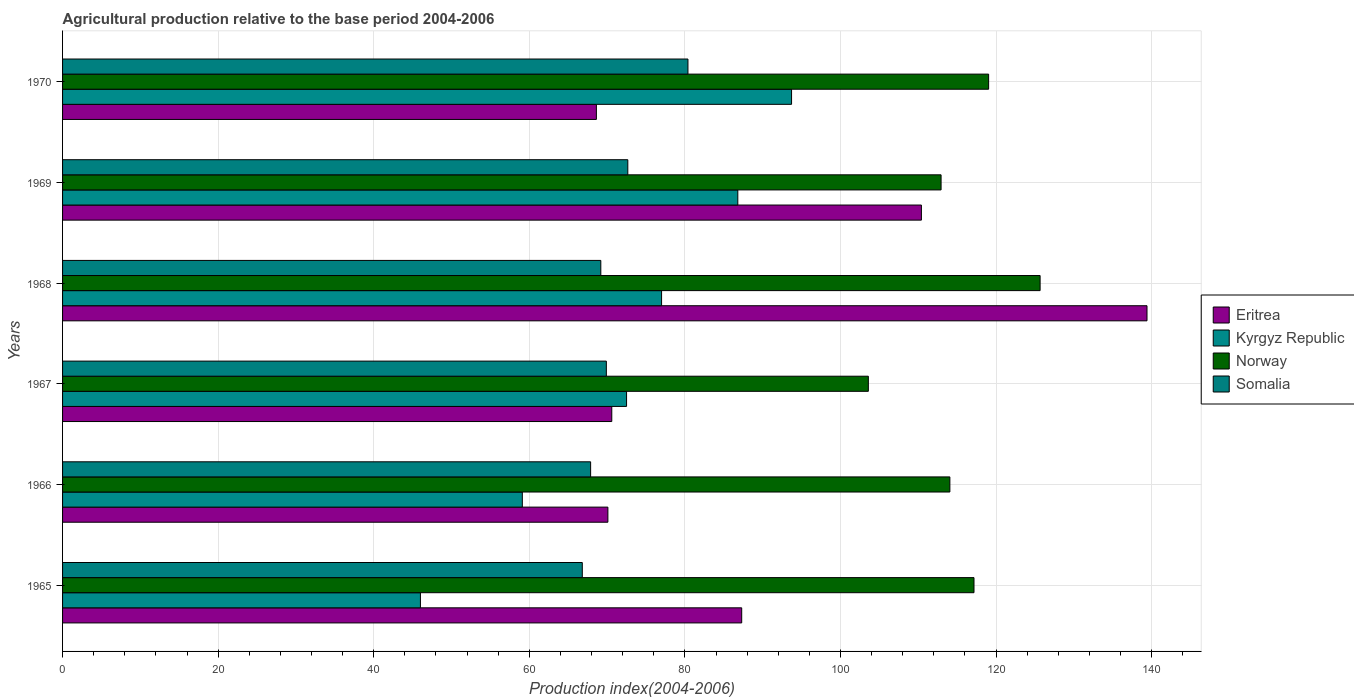How many different coloured bars are there?
Your response must be concise. 4. How many bars are there on the 6th tick from the bottom?
Give a very brief answer. 4. What is the label of the 4th group of bars from the top?
Keep it short and to the point. 1967. In how many cases, is the number of bars for a given year not equal to the number of legend labels?
Keep it short and to the point. 0. What is the agricultural production index in Eritrea in 1965?
Keep it short and to the point. 87.3. Across all years, what is the maximum agricultural production index in Somalia?
Your answer should be compact. 80.39. In which year was the agricultural production index in Somalia maximum?
Offer a very short reply. 1970. What is the total agricultural production index in Somalia in the graph?
Provide a short and direct response. 426.83. What is the difference between the agricultural production index in Eritrea in 1967 and that in 1969?
Offer a very short reply. -39.8. What is the difference between the agricultural production index in Somalia in 1970 and the agricultural production index in Norway in 1965?
Your response must be concise. -36.77. What is the average agricultural production index in Eritrea per year?
Offer a terse response. 91.07. In the year 1966, what is the difference between the agricultural production index in Eritrea and agricultural production index in Norway?
Ensure brevity in your answer.  -43.96. In how many years, is the agricultural production index in Kyrgyz Republic greater than 12 ?
Provide a succinct answer. 6. What is the ratio of the agricultural production index in Kyrgyz Republic in 1967 to that in 1970?
Your answer should be very brief. 0.77. Is the agricultural production index in Eritrea in 1965 less than that in 1969?
Make the answer very short. Yes. What is the difference between the highest and the second highest agricultural production index in Kyrgyz Republic?
Your answer should be very brief. 6.91. What is the difference between the highest and the lowest agricultural production index in Kyrgyz Republic?
Give a very brief answer. 47.71. In how many years, is the agricultural production index in Eritrea greater than the average agricultural production index in Eritrea taken over all years?
Offer a terse response. 2. What does the 1st bar from the top in 1969 represents?
Offer a terse response. Somalia. Is it the case that in every year, the sum of the agricultural production index in Norway and agricultural production index in Kyrgyz Republic is greater than the agricultural production index in Eritrea?
Ensure brevity in your answer.  Yes. How many years are there in the graph?
Ensure brevity in your answer.  6. Does the graph contain grids?
Give a very brief answer. Yes. Where does the legend appear in the graph?
Give a very brief answer. Center right. How many legend labels are there?
Give a very brief answer. 4. What is the title of the graph?
Provide a short and direct response. Agricultural production relative to the base period 2004-2006. Does "New Caledonia" appear as one of the legend labels in the graph?
Give a very brief answer. No. What is the label or title of the X-axis?
Provide a short and direct response. Production index(2004-2006). What is the label or title of the Y-axis?
Provide a short and direct response. Years. What is the Production index(2004-2006) of Eritrea in 1965?
Keep it short and to the point. 87.3. What is the Production index(2004-2006) in Norway in 1965?
Give a very brief answer. 117.16. What is the Production index(2004-2006) of Somalia in 1965?
Keep it short and to the point. 66.81. What is the Production index(2004-2006) of Eritrea in 1966?
Your answer should be very brief. 70.1. What is the Production index(2004-2006) in Kyrgyz Republic in 1966?
Keep it short and to the point. 59.1. What is the Production index(2004-2006) in Norway in 1966?
Keep it short and to the point. 114.06. What is the Production index(2004-2006) of Somalia in 1966?
Keep it short and to the point. 67.88. What is the Production index(2004-2006) in Eritrea in 1967?
Offer a very short reply. 70.6. What is the Production index(2004-2006) in Kyrgyz Republic in 1967?
Provide a succinct answer. 72.5. What is the Production index(2004-2006) of Norway in 1967?
Provide a short and direct response. 103.58. What is the Production index(2004-2006) of Somalia in 1967?
Provide a short and direct response. 69.9. What is the Production index(2004-2006) of Eritrea in 1968?
Offer a terse response. 139.4. What is the Production index(2004-2006) of Norway in 1968?
Give a very brief answer. 125.66. What is the Production index(2004-2006) of Somalia in 1968?
Keep it short and to the point. 69.19. What is the Production index(2004-2006) in Eritrea in 1969?
Offer a very short reply. 110.4. What is the Production index(2004-2006) of Kyrgyz Republic in 1969?
Offer a very short reply. 86.8. What is the Production index(2004-2006) in Norway in 1969?
Your response must be concise. 112.93. What is the Production index(2004-2006) in Somalia in 1969?
Your answer should be very brief. 72.66. What is the Production index(2004-2006) of Eritrea in 1970?
Offer a terse response. 68.62. What is the Production index(2004-2006) in Kyrgyz Republic in 1970?
Provide a succinct answer. 93.71. What is the Production index(2004-2006) of Norway in 1970?
Your response must be concise. 119.04. What is the Production index(2004-2006) of Somalia in 1970?
Offer a very short reply. 80.39. Across all years, what is the maximum Production index(2004-2006) in Eritrea?
Offer a terse response. 139.4. Across all years, what is the maximum Production index(2004-2006) of Kyrgyz Republic?
Your answer should be compact. 93.71. Across all years, what is the maximum Production index(2004-2006) in Norway?
Provide a succinct answer. 125.66. Across all years, what is the maximum Production index(2004-2006) of Somalia?
Offer a terse response. 80.39. Across all years, what is the minimum Production index(2004-2006) of Eritrea?
Your answer should be compact. 68.62. Across all years, what is the minimum Production index(2004-2006) in Kyrgyz Republic?
Offer a terse response. 46. Across all years, what is the minimum Production index(2004-2006) of Norway?
Your response must be concise. 103.58. Across all years, what is the minimum Production index(2004-2006) of Somalia?
Offer a very short reply. 66.81. What is the total Production index(2004-2006) in Eritrea in the graph?
Give a very brief answer. 546.42. What is the total Production index(2004-2006) in Kyrgyz Republic in the graph?
Your answer should be very brief. 435.11. What is the total Production index(2004-2006) in Norway in the graph?
Provide a short and direct response. 692.43. What is the total Production index(2004-2006) of Somalia in the graph?
Give a very brief answer. 426.83. What is the difference between the Production index(2004-2006) in Kyrgyz Republic in 1965 and that in 1966?
Keep it short and to the point. -13.1. What is the difference between the Production index(2004-2006) in Norway in 1965 and that in 1966?
Ensure brevity in your answer.  3.1. What is the difference between the Production index(2004-2006) of Somalia in 1965 and that in 1966?
Offer a very short reply. -1.07. What is the difference between the Production index(2004-2006) in Eritrea in 1965 and that in 1967?
Your answer should be compact. 16.7. What is the difference between the Production index(2004-2006) in Kyrgyz Republic in 1965 and that in 1967?
Make the answer very short. -26.5. What is the difference between the Production index(2004-2006) in Norway in 1965 and that in 1967?
Ensure brevity in your answer.  13.58. What is the difference between the Production index(2004-2006) of Somalia in 1965 and that in 1967?
Your response must be concise. -3.09. What is the difference between the Production index(2004-2006) of Eritrea in 1965 and that in 1968?
Your response must be concise. -52.1. What is the difference between the Production index(2004-2006) of Kyrgyz Republic in 1965 and that in 1968?
Your answer should be compact. -31. What is the difference between the Production index(2004-2006) in Somalia in 1965 and that in 1968?
Provide a short and direct response. -2.38. What is the difference between the Production index(2004-2006) of Eritrea in 1965 and that in 1969?
Give a very brief answer. -23.1. What is the difference between the Production index(2004-2006) in Kyrgyz Republic in 1965 and that in 1969?
Make the answer very short. -40.8. What is the difference between the Production index(2004-2006) of Norway in 1965 and that in 1969?
Offer a terse response. 4.23. What is the difference between the Production index(2004-2006) in Somalia in 1965 and that in 1969?
Offer a terse response. -5.85. What is the difference between the Production index(2004-2006) of Eritrea in 1965 and that in 1970?
Your answer should be very brief. 18.68. What is the difference between the Production index(2004-2006) of Kyrgyz Republic in 1965 and that in 1970?
Offer a very short reply. -47.71. What is the difference between the Production index(2004-2006) in Norway in 1965 and that in 1970?
Your answer should be very brief. -1.88. What is the difference between the Production index(2004-2006) of Somalia in 1965 and that in 1970?
Offer a terse response. -13.58. What is the difference between the Production index(2004-2006) of Norway in 1966 and that in 1967?
Your answer should be very brief. 10.48. What is the difference between the Production index(2004-2006) of Somalia in 1966 and that in 1967?
Provide a succinct answer. -2.02. What is the difference between the Production index(2004-2006) of Eritrea in 1966 and that in 1968?
Your answer should be very brief. -69.3. What is the difference between the Production index(2004-2006) of Kyrgyz Republic in 1966 and that in 1968?
Give a very brief answer. -17.9. What is the difference between the Production index(2004-2006) of Somalia in 1966 and that in 1968?
Your answer should be very brief. -1.31. What is the difference between the Production index(2004-2006) of Eritrea in 1966 and that in 1969?
Offer a terse response. -40.3. What is the difference between the Production index(2004-2006) in Kyrgyz Republic in 1966 and that in 1969?
Your answer should be compact. -27.7. What is the difference between the Production index(2004-2006) of Norway in 1966 and that in 1969?
Offer a terse response. 1.13. What is the difference between the Production index(2004-2006) in Somalia in 1966 and that in 1969?
Your response must be concise. -4.78. What is the difference between the Production index(2004-2006) in Eritrea in 1966 and that in 1970?
Your answer should be very brief. 1.48. What is the difference between the Production index(2004-2006) in Kyrgyz Republic in 1966 and that in 1970?
Offer a terse response. -34.61. What is the difference between the Production index(2004-2006) in Norway in 1966 and that in 1970?
Provide a succinct answer. -4.98. What is the difference between the Production index(2004-2006) in Somalia in 1966 and that in 1970?
Your answer should be very brief. -12.51. What is the difference between the Production index(2004-2006) of Eritrea in 1967 and that in 1968?
Provide a short and direct response. -68.8. What is the difference between the Production index(2004-2006) of Norway in 1967 and that in 1968?
Your answer should be very brief. -22.08. What is the difference between the Production index(2004-2006) of Somalia in 1967 and that in 1968?
Your answer should be compact. 0.71. What is the difference between the Production index(2004-2006) in Eritrea in 1967 and that in 1969?
Provide a succinct answer. -39.8. What is the difference between the Production index(2004-2006) of Kyrgyz Republic in 1967 and that in 1969?
Your answer should be compact. -14.3. What is the difference between the Production index(2004-2006) in Norway in 1967 and that in 1969?
Keep it short and to the point. -9.35. What is the difference between the Production index(2004-2006) in Somalia in 1967 and that in 1969?
Keep it short and to the point. -2.76. What is the difference between the Production index(2004-2006) in Eritrea in 1967 and that in 1970?
Your answer should be compact. 1.98. What is the difference between the Production index(2004-2006) in Kyrgyz Republic in 1967 and that in 1970?
Ensure brevity in your answer.  -21.21. What is the difference between the Production index(2004-2006) of Norway in 1967 and that in 1970?
Provide a short and direct response. -15.46. What is the difference between the Production index(2004-2006) of Somalia in 1967 and that in 1970?
Keep it short and to the point. -10.49. What is the difference between the Production index(2004-2006) of Kyrgyz Republic in 1968 and that in 1969?
Your answer should be very brief. -9.8. What is the difference between the Production index(2004-2006) of Norway in 1968 and that in 1969?
Give a very brief answer. 12.73. What is the difference between the Production index(2004-2006) of Somalia in 1968 and that in 1969?
Offer a very short reply. -3.47. What is the difference between the Production index(2004-2006) in Eritrea in 1968 and that in 1970?
Keep it short and to the point. 70.78. What is the difference between the Production index(2004-2006) of Kyrgyz Republic in 1968 and that in 1970?
Your response must be concise. -16.71. What is the difference between the Production index(2004-2006) in Norway in 1968 and that in 1970?
Provide a short and direct response. 6.62. What is the difference between the Production index(2004-2006) in Somalia in 1968 and that in 1970?
Your answer should be compact. -11.2. What is the difference between the Production index(2004-2006) of Eritrea in 1969 and that in 1970?
Your response must be concise. 41.78. What is the difference between the Production index(2004-2006) in Kyrgyz Republic in 1969 and that in 1970?
Offer a very short reply. -6.91. What is the difference between the Production index(2004-2006) in Norway in 1969 and that in 1970?
Provide a succinct answer. -6.11. What is the difference between the Production index(2004-2006) in Somalia in 1969 and that in 1970?
Your response must be concise. -7.73. What is the difference between the Production index(2004-2006) of Eritrea in 1965 and the Production index(2004-2006) of Kyrgyz Republic in 1966?
Provide a short and direct response. 28.2. What is the difference between the Production index(2004-2006) of Eritrea in 1965 and the Production index(2004-2006) of Norway in 1966?
Keep it short and to the point. -26.76. What is the difference between the Production index(2004-2006) in Eritrea in 1965 and the Production index(2004-2006) in Somalia in 1966?
Provide a succinct answer. 19.42. What is the difference between the Production index(2004-2006) in Kyrgyz Republic in 1965 and the Production index(2004-2006) in Norway in 1966?
Your response must be concise. -68.06. What is the difference between the Production index(2004-2006) in Kyrgyz Republic in 1965 and the Production index(2004-2006) in Somalia in 1966?
Make the answer very short. -21.88. What is the difference between the Production index(2004-2006) of Norway in 1965 and the Production index(2004-2006) of Somalia in 1966?
Keep it short and to the point. 49.28. What is the difference between the Production index(2004-2006) of Eritrea in 1965 and the Production index(2004-2006) of Norway in 1967?
Make the answer very short. -16.28. What is the difference between the Production index(2004-2006) in Kyrgyz Republic in 1965 and the Production index(2004-2006) in Norway in 1967?
Make the answer very short. -57.58. What is the difference between the Production index(2004-2006) in Kyrgyz Republic in 1965 and the Production index(2004-2006) in Somalia in 1967?
Your response must be concise. -23.9. What is the difference between the Production index(2004-2006) in Norway in 1965 and the Production index(2004-2006) in Somalia in 1967?
Your response must be concise. 47.26. What is the difference between the Production index(2004-2006) of Eritrea in 1965 and the Production index(2004-2006) of Kyrgyz Republic in 1968?
Your response must be concise. 10.3. What is the difference between the Production index(2004-2006) of Eritrea in 1965 and the Production index(2004-2006) of Norway in 1968?
Give a very brief answer. -38.36. What is the difference between the Production index(2004-2006) in Eritrea in 1965 and the Production index(2004-2006) in Somalia in 1968?
Offer a very short reply. 18.11. What is the difference between the Production index(2004-2006) of Kyrgyz Republic in 1965 and the Production index(2004-2006) of Norway in 1968?
Your response must be concise. -79.66. What is the difference between the Production index(2004-2006) of Kyrgyz Republic in 1965 and the Production index(2004-2006) of Somalia in 1968?
Ensure brevity in your answer.  -23.19. What is the difference between the Production index(2004-2006) of Norway in 1965 and the Production index(2004-2006) of Somalia in 1968?
Ensure brevity in your answer.  47.97. What is the difference between the Production index(2004-2006) of Eritrea in 1965 and the Production index(2004-2006) of Norway in 1969?
Make the answer very short. -25.63. What is the difference between the Production index(2004-2006) of Eritrea in 1965 and the Production index(2004-2006) of Somalia in 1969?
Keep it short and to the point. 14.64. What is the difference between the Production index(2004-2006) of Kyrgyz Republic in 1965 and the Production index(2004-2006) of Norway in 1969?
Give a very brief answer. -66.93. What is the difference between the Production index(2004-2006) of Kyrgyz Republic in 1965 and the Production index(2004-2006) of Somalia in 1969?
Offer a terse response. -26.66. What is the difference between the Production index(2004-2006) of Norway in 1965 and the Production index(2004-2006) of Somalia in 1969?
Your response must be concise. 44.5. What is the difference between the Production index(2004-2006) of Eritrea in 1965 and the Production index(2004-2006) of Kyrgyz Republic in 1970?
Keep it short and to the point. -6.41. What is the difference between the Production index(2004-2006) in Eritrea in 1965 and the Production index(2004-2006) in Norway in 1970?
Your response must be concise. -31.74. What is the difference between the Production index(2004-2006) of Eritrea in 1965 and the Production index(2004-2006) of Somalia in 1970?
Keep it short and to the point. 6.91. What is the difference between the Production index(2004-2006) of Kyrgyz Republic in 1965 and the Production index(2004-2006) of Norway in 1970?
Ensure brevity in your answer.  -73.04. What is the difference between the Production index(2004-2006) of Kyrgyz Republic in 1965 and the Production index(2004-2006) of Somalia in 1970?
Provide a short and direct response. -34.39. What is the difference between the Production index(2004-2006) in Norway in 1965 and the Production index(2004-2006) in Somalia in 1970?
Make the answer very short. 36.77. What is the difference between the Production index(2004-2006) in Eritrea in 1966 and the Production index(2004-2006) in Norway in 1967?
Your answer should be compact. -33.48. What is the difference between the Production index(2004-2006) in Eritrea in 1966 and the Production index(2004-2006) in Somalia in 1967?
Offer a terse response. 0.2. What is the difference between the Production index(2004-2006) of Kyrgyz Republic in 1966 and the Production index(2004-2006) of Norway in 1967?
Offer a terse response. -44.48. What is the difference between the Production index(2004-2006) of Kyrgyz Republic in 1966 and the Production index(2004-2006) of Somalia in 1967?
Offer a terse response. -10.8. What is the difference between the Production index(2004-2006) of Norway in 1966 and the Production index(2004-2006) of Somalia in 1967?
Your response must be concise. 44.16. What is the difference between the Production index(2004-2006) of Eritrea in 1966 and the Production index(2004-2006) of Norway in 1968?
Your answer should be very brief. -55.56. What is the difference between the Production index(2004-2006) in Eritrea in 1966 and the Production index(2004-2006) in Somalia in 1968?
Ensure brevity in your answer.  0.91. What is the difference between the Production index(2004-2006) in Kyrgyz Republic in 1966 and the Production index(2004-2006) in Norway in 1968?
Your answer should be very brief. -66.56. What is the difference between the Production index(2004-2006) of Kyrgyz Republic in 1966 and the Production index(2004-2006) of Somalia in 1968?
Offer a terse response. -10.09. What is the difference between the Production index(2004-2006) in Norway in 1966 and the Production index(2004-2006) in Somalia in 1968?
Make the answer very short. 44.87. What is the difference between the Production index(2004-2006) of Eritrea in 1966 and the Production index(2004-2006) of Kyrgyz Republic in 1969?
Offer a terse response. -16.7. What is the difference between the Production index(2004-2006) of Eritrea in 1966 and the Production index(2004-2006) of Norway in 1969?
Make the answer very short. -42.83. What is the difference between the Production index(2004-2006) in Eritrea in 1966 and the Production index(2004-2006) in Somalia in 1969?
Offer a very short reply. -2.56. What is the difference between the Production index(2004-2006) of Kyrgyz Republic in 1966 and the Production index(2004-2006) of Norway in 1969?
Give a very brief answer. -53.83. What is the difference between the Production index(2004-2006) in Kyrgyz Republic in 1966 and the Production index(2004-2006) in Somalia in 1969?
Provide a short and direct response. -13.56. What is the difference between the Production index(2004-2006) in Norway in 1966 and the Production index(2004-2006) in Somalia in 1969?
Offer a very short reply. 41.4. What is the difference between the Production index(2004-2006) in Eritrea in 1966 and the Production index(2004-2006) in Kyrgyz Republic in 1970?
Provide a short and direct response. -23.61. What is the difference between the Production index(2004-2006) in Eritrea in 1966 and the Production index(2004-2006) in Norway in 1970?
Provide a short and direct response. -48.94. What is the difference between the Production index(2004-2006) of Eritrea in 1966 and the Production index(2004-2006) of Somalia in 1970?
Offer a very short reply. -10.29. What is the difference between the Production index(2004-2006) in Kyrgyz Republic in 1966 and the Production index(2004-2006) in Norway in 1970?
Offer a terse response. -59.94. What is the difference between the Production index(2004-2006) in Kyrgyz Republic in 1966 and the Production index(2004-2006) in Somalia in 1970?
Make the answer very short. -21.29. What is the difference between the Production index(2004-2006) in Norway in 1966 and the Production index(2004-2006) in Somalia in 1970?
Make the answer very short. 33.67. What is the difference between the Production index(2004-2006) in Eritrea in 1967 and the Production index(2004-2006) in Kyrgyz Republic in 1968?
Ensure brevity in your answer.  -6.4. What is the difference between the Production index(2004-2006) in Eritrea in 1967 and the Production index(2004-2006) in Norway in 1968?
Ensure brevity in your answer.  -55.06. What is the difference between the Production index(2004-2006) in Eritrea in 1967 and the Production index(2004-2006) in Somalia in 1968?
Provide a succinct answer. 1.41. What is the difference between the Production index(2004-2006) in Kyrgyz Republic in 1967 and the Production index(2004-2006) in Norway in 1968?
Offer a very short reply. -53.16. What is the difference between the Production index(2004-2006) of Kyrgyz Republic in 1967 and the Production index(2004-2006) of Somalia in 1968?
Offer a terse response. 3.31. What is the difference between the Production index(2004-2006) in Norway in 1967 and the Production index(2004-2006) in Somalia in 1968?
Give a very brief answer. 34.39. What is the difference between the Production index(2004-2006) of Eritrea in 1967 and the Production index(2004-2006) of Kyrgyz Republic in 1969?
Give a very brief answer. -16.2. What is the difference between the Production index(2004-2006) of Eritrea in 1967 and the Production index(2004-2006) of Norway in 1969?
Provide a succinct answer. -42.33. What is the difference between the Production index(2004-2006) in Eritrea in 1967 and the Production index(2004-2006) in Somalia in 1969?
Provide a succinct answer. -2.06. What is the difference between the Production index(2004-2006) of Kyrgyz Republic in 1967 and the Production index(2004-2006) of Norway in 1969?
Make the answer very short. -40.43. What is the difference between the Production index(2004-2006) in Kyrgyz Republic in 1967 and the Production index(2004-2006) in Somalia in 1969?
Your response must be concise. -0.16. What is the difference between the Production index(2004-2006) of Norway in 1967 and the Production index(2004-2006) of Somalia in 1969?
Ensure brevity in your answer.  30.92. What is the difference between the Production index(2004-2006) of Eritrea in 1967 and the Production index(2004-2006) of Kyrgyz Republic in 1970?
Offer a terse response. -23.11. What is the difference between the Production index(2004-2006) of Eritrea in 1967 and the Production index(2004-2006) of Norway in 1970?
Make the answer very short. -48.44. What is the difference between the Production index(2004-2006) of Eritrea in 1967 and the Production index(2004-2006) of Somalia in 1970?
Provide a succinct answer. -9.79. What is the difference between the Production index(2004-2006) of Kyrgyz Republic in 1967 and the Production index(2004-2006) of Norway in 1970?
Offer a very short reply. -46.54. What is the difference between the Production index(2004-2006) of Kyrgyz Republic in 1967 and the Production index(2004-2006) of Somalia in 1970?
Give a very brief answer. -7.89. What is the difference between the Production index(2004-2006) of Norway in 1967 and the Production index(2004-2006) of Somalia in 1970?
Keep it short and to the point. 23.19. What is the difference between the Production index(2004-2006) of Eritrea in 1968 and the Production index(2004-2006) of Kyrgyz Republic in 1969?
Ensure brevity in your answer.  52.6. What is the difference between the Production index(2004-2006) of Eritrea in 1968 and the Production index(2004-2006) of Norway in 1969?
Keep it short and to the point. 26.47. What is the difference between the Production index(2004-2006) in Eritrea in 1968 and the Production index(2004-2006) in Somalia in 1969?
Provide a succinct answer. 66.74. What is the difference between the Production index(2004-2006) of Kyrgyz Republic in 1968 and the Production index(2004-2006) of Norway in 1969?
Offer a very short reply. -35.93. What is the difference between the Production index(2004-2006) of Kyrgyz Republic in 1968 and the Production index(2004-2006) of Somalia in 1969?
Offer a very short reply. 4.34. What is the difference between the Production index(2004-2006) in Norway in 1968 and the Production index(2004-2006) in Somalia in 1969?
Keep it short and to the point. 53. What is the difference between the Production index(2004-2006) in Eritrea in 1968 and the Production index(2004-2006) in Kyrgyz Republic in 1970?
Your answer should be very brief. 45.69. What is the difference between the Production index(2004-2006) of Eritrea in 1968 and the Production index(2004-2006) of Norway in 1970?
Offer a very short reply. 20.36. What is the difference between the Production index(2004-2006) in Eritrea in 1968 and the Production index(2004-2006) in Somalia in 1970?
Provide a succinct answer. 59.01. What is the difference between the Production index(2004-2006) in Kyrgyz Republic in 1968 and the Production index(2004-2006) in Norway in 1970?
Provide a short and direct response. -42.04. What is the difference between the Production index(2004-2006) in Kyrgyz Republic in 1968 and the Production index(2004-2006) in Somalia in 1970?
Your response must be concise. -3.39. What is the difference between the Production index(2004-2006) of Norway in 1968 and the Production index(2004-2006) of Somalia in 1970?
Ensure brevity in your answer.  45.27. What is the difference between the Production index(2004-2006) of Eritrea in 1969 and the Production index(2004-2006) of Kyrgyz Republic in 1970?
Keep it short and to the point. 16.69. What is the difference between the Production index(2004-2006) in Eritrea in 1969 and the Production index(2004-2006) in Norway in 1970?
Provide a succinct answer. -8.64. What is the difference between the Production index(2004-2006) in Eritrea in 1969 and the Production index(2004-2006) in Somalia in 1970?
Make the answer very short. 30.01. What is the difference between the Production index(2004-2006) in Kyrgyz Republic in 1969 and the Production index(2004-2006) in Norway in 1970?
Give a very brief answer. -32.24. What is the difference between the Production index(2004-2006) in Kyrgyz Republic in 1969 and the Production index(2004-2006) in Somalia in 1970?
Keep it short and to the point. 6.41. What is the difference between the Production index(2004-2006) in Norway in 1969 and the Production index(2004-2006) in Somalia in 1970?
Offer a very short reply. 32.54. What is the average Production index(2004-2006) of Eritrea per year?
Keep it short and to the point. 91.07. What is the average Production index(2004-2006) in Kyrgyz Republic per year?
Your answer should be very brief. 72.52. What is the average Production index(2004-2006) in Norway per year?
Ensure brevity in your answer.  115.41. What is the average Production index(2004-2006) in Somalia per year?
Provide a short and direct response. 71.14. In the year 1965, what is the difference between the Production index(2004-2006) in Eritrea and Production index(2004-2006) in Kyrgyz Republic?
Provide a succinct answer. 41.3. In the year 1965, what is the difference between the Production index(2004-2006) in Eritrea and Production index(2004-2006) in Norway?
Your answer should be compact. -29.86. In the year 1965, what is the difference between the Production index(2004-2006) in Eritrea and Production index(2004-2006) in Somalia?
Provide a short and direct response. 20.49. In the year 1965, what is the difference between the Production index(2004-2006) of Kyrgyz Republic and Production index(2004-2006) of Norway?
Your answer should be very brief. -71.16. In the year 1965, what is the difference between the Production index(2004-2006) of Kyrgyz Republic and Production index(2004-2006) of Somalia?
Give a very brief answer. -20.81. In the year 1965, what is the difference between the Production index(2004-2006) of Norway and Production index(2004-2006) of Somalia?
Keep it short and to the point. 50.35. In the year 1966, what is the difference between the Production index(2004-2006) of Eritrea and Production index(2004-2006) of Kyrgyz Republic?
Provide a succinct answer. 11. In the year 1966, what is the difference between the Production index(2004-2006) in Eritrea and Production index(2004-2006) in Norway?
Your answer should be compact. -43.96. In the year 1966, what is the difference between the Production index(2004-2006) in Eritrea and Production index(2004-2006) in Somalia?
Your answer should be very brief. 2.22. In the year 1966, what is the difference between the Production index(2004-2006) of Kyrgyz Republic and Production index(2004-2006) of Norway?
Your response must be concise. -54.96. In the year 1966, what is the difference between the Production index(2004-2006) in Kyrgyz Republic and Production index(2004-2006) in Somalia?
Keep it short and to the point. -8.78. In the year 1966, what is the difference between the Production index(2004-2006) of Norway and Production index(2004-2006) of Somalia?
Provide a short and direct response. 46.18. In the year 1967, what is the difference between the Production index(2004-2006) of Eritrea and Production index(2004-2006) of Kyrgyz Republic?
Keep it short and to the point. -1.9. In the year 1967, what is the difference between the Production index(2004-2006) in Eritrea and Production index(2004-2006) in Norway?
Keep it short and to the point. -32.98. In the year 1967, what is the difference between the Production index(2004-2006) in Eritrea and Production index(2004-2006) in Somalia?
Make the answer very short. 0.7. In the year 1967, what is the difference between the Production index(2004-2006) of Kyrgyz Republic and Production index(2004-2006) of Norway?
Give a very brief answer. -31.08. In the year 1967, what is the difference between the Production index(2004-2006) in Norway and Production index(2004-2006) in Somalia?
Provide a short and direct response. 33.68. In the year 1968, what is the difference between the Production index(2004-2006) in Eritrea and Production index(2004-2006) in Kyrgyz Republic?
Provide a succinct answer. 62.4. In the year 1968, what is the difference between the Production index(2004-2006) of Eritrea and Production index(2004-2006) of Norway?
Your response must be concise. 13.74. In the year 1968, what is the difference between the Production index(2004-2006) in Eritrea and Production index(2004-2006) in Somalia?
Provide a succinct answer. 70.21. In the year 1968, what is the difference between the Production index(2004-2006) in Kyrgyz Republic and Production index(2004-2006) in Norway?
Ensure brevity in your answer.  -48.66. In the year 1968, what is the difference between the Production index(2004-2006) of Kyrgyz Republic and Production index(2004-2006) of Somalia?
Provide a succinct answer. 7.81. In the year 1968, what is the difference between the Production index(2004-2006) of Norway and Production index(2004-2006) of Somalia?
Your answer should be very brief. 56.47. In the year 1969, what is the difference between the Production index(2004-2006) in Eritrea and Production index(2004-2006) in Kyrgyz Republic?
Offer a very short reply. 23.6. In the year 1969, what is the difference between the Production index(2004-2006) in Eritrea and Production index(2004-2006) in Norway?
Your answer should be compact. -2.53. In the year 1969, what is the difference between the Production index(2004-2006) in Eritrea and Production index(2004-2006) in Somalia?
Offer a terse response. 37.74. In the year 1969, what is the difference between the Production index(2004-2006) of Kyrgyz Republic and Production index(2004-2006) of Norway?
Offer a very short reply. -26.13. In the year 1969, what is the difference between the Production index(2004-2006) in Kyrgyz Republic and Production index(2004-2006) in Somalia?
Keep it short and to the point. 14.14. In the year 1969, what is the difference between the Production index(2004-2006) of Norway and Production index(2004-2006) of Somalia?
Your answer should be very brief. 40.27. In the year 1970, what is the difference between the Production index(2004-2006) in Eritrea and Production index(2004-2006) in Kyrgyz Republic?
Your answer should be very brief. -25.09. In the year 1970, what is the difference between the Production index(2004-2006) of Eritrea and Production index(2004-2006) of Norway?
Offer a very short reply. -50.42. In the year 1970, what is the difference between the Production index(2004-2006) in Eritrea and Production index(2004-2006) in Somalia?
Provide a short and direct response. -11.77. In the year 1970, what is the difference between the Production index(2004-2006) of Kyrgyz Republic and Production index(2004-2006) of Norway?
Ensure brevity in your answer.  -25.33. In the year 1970, what is the difference between the Production index(2004-2006) in Kyrgyz Republic and Production index(2004-2006) in Somalia?
Make the answer very short. 13.32. In the year 1970, what is the difference between the Production index(2004-2006) of Norway and Production index(2004-2006) of Somalia?
Offer a very short reply. 38.65. What is the ratio of the Production index(2004-2006) of Eritrea in 1965 to that in 1966?
Offer a very short reply. 1.25. What is the ratio of the Production index(2004-2006) of Kyrgyz Republic in 1965 to that in 1966?
Provide a succinct answer. 0.78. What is the ratio of the Production index(2004-2006) in Norway in 1965 to that in 1966?
Provide a succinct answer. 1.03. What is the ratio of the Production index(2004-2006) of Somalia in 1965 to that in 1966?
Offer a terse response. 0.98. What is the ratio of the Production index(2004-2006) of Eritrea in 1965 to that in 1967?
Offer a terse response. 1.24. What is the ratio of the Production index(2004-2006) of Kyrgyz Republic in 1965 to that in 1967?
Provide a succinct answer. 0.63. What is the ratio of the Production index(2004-2006) in Norway in 1965 to that in 1967?
Offer a very short reply. 1.13. What is the ratio of the Production index(2004-2006) of Somalia in 1965 to that in 1967?
Your answer should be very brief. 0.96. What is the ratio of the Production index(2004-2006) in Eritrea in 1965 to that in 1968?
Offer a terse response. 0.63. What is the ratio of the Production index(2004-2006) in Kyrgyz Republic in 1965 to that in 1968?
Offer a terse response. 0.6. What is the ratio of the Production index(2004-2006) of Norway in 1965 to that in 1968?
Your response must be concise. 0.93. What is the ratio of the Production index(2004-2006) of Somalia in 1965 to that in 1968?
Your response must be concise. 0.97. What is the ratio of the Production index(2004-2006) in Eritrea in 1965 to that in 1969?
Keep it short and to the point. 0.79. What is the ratio of the Production index(2004-2006) in Kyrgyz Republic in 1965 to that in 1969?
Your answer should be very brief. 0.53. What is the ratio of the Production index(2004-2006) in Norway in 1965 to that in 1969?
Your answer should be compact. 1.04. What is the ratio of the Production index(2004-2006) of Somalia in 1965 to that in 1969?
Your response must be concise. 0.92. What is the ratio of the Production index(2004-2006) in Eritrea in 1965 to that in 1970?
Your answer should be very brief. 1.27. What is the ratio of the Production index(2004-2006) in Kyrgyz Republic in 1965 to that in 1970?
Provide a succinct answer. 0.49. What is the ratio of the Production index(2004-2006) in Norway in 1965 to that in 1970?
Give a very brief answer. 0.98. What is the ratio of the Production index(2004-2006) of Somalia in 1965 to that in 1970?
Provide a short and direct response. 0.83. What is the ratio of the Production index(2004-2006) of Eritrea in 1966 to that in 1967?
Make the answer very short. 0.99. What is the ratio of the Production index(2004-2006) of Kyrgyz Republic in 1966 to that in 1967?
Offer a terse response. 0.82. What is the ratio of the Production index(2004-2006) of Norway in 1966 to that in 1967?
Make the answer very short. 1.1. What is the ratio of the Production index(2004-2006) of Somalia in 1966 to that in 1967?
Ensure brevity in your answer.  0.97. What is the ratio of the Production index(2004-2006) of Eritrea in 1966 to that in 1968?
Your answer should be compact. 0.5. What is the ratio of the Production index(2004-2006) of Kyrgyz Republic in 1966 to that in 1968?
Your response must be concise. 0.77. What is the ratio of the Production index(2004-2006) in Norway in 1966 to that in 1968?
Make the answer very short. 0.91. What is the ratio of the Production index(2004-2006) of Somalia in 1966 to that in 1968?
Ensure brevity in your answer.  0.98. What is the ratio of the Production index(2004-2006) of Eritrea in 1966 to that in 1969?
Keep it short and to the point. 0.64. What is the ratio of the Production index(2004-2006) of Kyrgyz Republic in 1966 to that in 1969?
Give a very brief answer. 0.68. What is the ratio of the Production index(2004-2006) of Somalia in 1966 to that in 1969?
Your answer should be compact. 0.93. What is the ratio of the Production index(2004-2006) in Eritrea in 1966 to that in 1970?
Provide a succinct answer. 1.02. What is the ratio of the Production index(2004-2006) in Kyrgyz Republic in 1966 to that in 1970?
Provide a succinct answer. 0.63. What is the ratio of the Production index(2004-2006) of Norway in 1966 to that in 1970?
Keep it short and to the point. 0.96. What is the ratio of the Production index(2004-2006) of Somalia in 1966 to that in 1970?
Provide a short and direct response. 0.84. What is the ratio of the Production index(2004-2006) in Eritrea in 1967 to that in 1968?
Offer a very short reply. 0.51. What is the ratio of the Production index(2004-2006) in Kyrgyz Republic in 1967 to that in 1968?
Provide a short and direct response. 0.94. What is the ratio of the Production index(2004-2006) of Norway in 1967 to that in 1968?
Your answer should be compact. 0.82. What is the ratio of the Production index(2004-2006) of Somalia in 1967 to that in 1968?
Ensure brevity in your answer.  1.01. What is the ratio of the Production index(2004-2006) of Eritrea in 1967 to that in 1969?
Ensure brevity in your answer.  0.64. What is the ratio of the Production index(2004-2006) in Kyrgyz Republic in 1967 to that in 1969?
Ensure brevity in your answer.  0.84. What is the ratio of the Production index(2004-2006) of Norway in 1967 to that in 1969?
Provide a succinct answer. 0.92. What is the ratio of the Production index(2004-2006) of Somalia in 1967 to that in 1969?
Ensure brevity in your answer.  0.96. What is the ratio of the Production index(2004-2006) in Eritrea in 1967 to that in 1970?
Give a very brief answer. 1.03. What is the ratio of the Production index(2004-2006) in Kyrgyz Republic in 1967 to that in 1970?
Your response must be concise. 0.77. What is the ratio of the Production index(2004-2006) of Norway in 1967 to that in 1970?
Offer a terse response. 0.87. What is the ratio of the Production index(2004-2006) of Somalia in 1967 to that in 1970?
Your answer should be very brief. 0.87. What is the ratio of the Production index(2004-2006) of Eritrea in 1968 to that in 1969?
Offer a very short reply. 1.26. What is the ratio of the Production index(2004-2006) in Kyrgyz Republic in 1968 to that in 1969?
Your answer should be very brief. 0.89. What is the ratio of the Production index(2004-2006) in Norway in 1968 to that in 1969?
Your response must be concise. 1.11. What is the ratio of the Production index(2004-2006) of Somalia in 1968 to that in 1969?
Provide a short and direct response. 0.95. What is the ratio of the Production index(2004-2006) in Eritrea in 1968 to that in 1970?
Provide a succinct answer. 2.03. What is the ratio of the Production index(2004-2006) in Kyrgyz Republic in 1968 to that in 1970?
Your response must be concise. 0.82. What is the ratio of the Production index(2004-2006) of Norway in 1968 to that in 1970?
Ensure brevity in your answer.  1.06. What is the ratio of the Production index(2004-2006) in Somalia in 1968 to that in 1970?
Your response must be concise. 0.86. What is the ratio of the Production index(2004-2006) in Eritrea in 1969 to that in 1970?
Provide a succinct answer. 1.61. What is the ratio of the Production index(2004-2006) of Kyrgyz Republic in 1969 to that in 1970?
Keep it short and to the point. 0.93. What is the ratio of the Production index(2004-2006) in Norway in 1969 to that in 1970?
Your response must be concise. 0.95. What is the ratio of the Production index(2004-2006) in Somalia in 1969 to that in 1970?
Provide a short and direct response. 0.9. What is the difference between the highest and the second highest Production index(2004-2006) in Eritrea?
Give a very brief answer. 29. What is the difference between the highest and the second highest Production index(2004-2006) in Kyrgyz Republic?
Ensure brevity in your answer.  6.91. What is the difference between the highest and the second highest Production index(2004-2006) in Norway?
Offer a terse response. 6.62. What is the difference between the highest and the second highest Production index(2004-2006) of Somalia?
Ensure brevity in your answer.  7.73. What is the difference between the highest and the lowest Production index(2004-2006) in Eritrea?
Your answer should be very brief. 70.78. What is the difference between the highest and the lowest Production index(2004-2006) of Kyrgyz Republic?
Your answer should be compact. 47.71. What is the difference between the highest and the lowest Production index(2004-2006) of Norway?
Your answer should be compact. 22.08. What is the difference between the highest and the lowest Production index(2004-2006) in Somalia?
Your response must be concise. 13.58. 